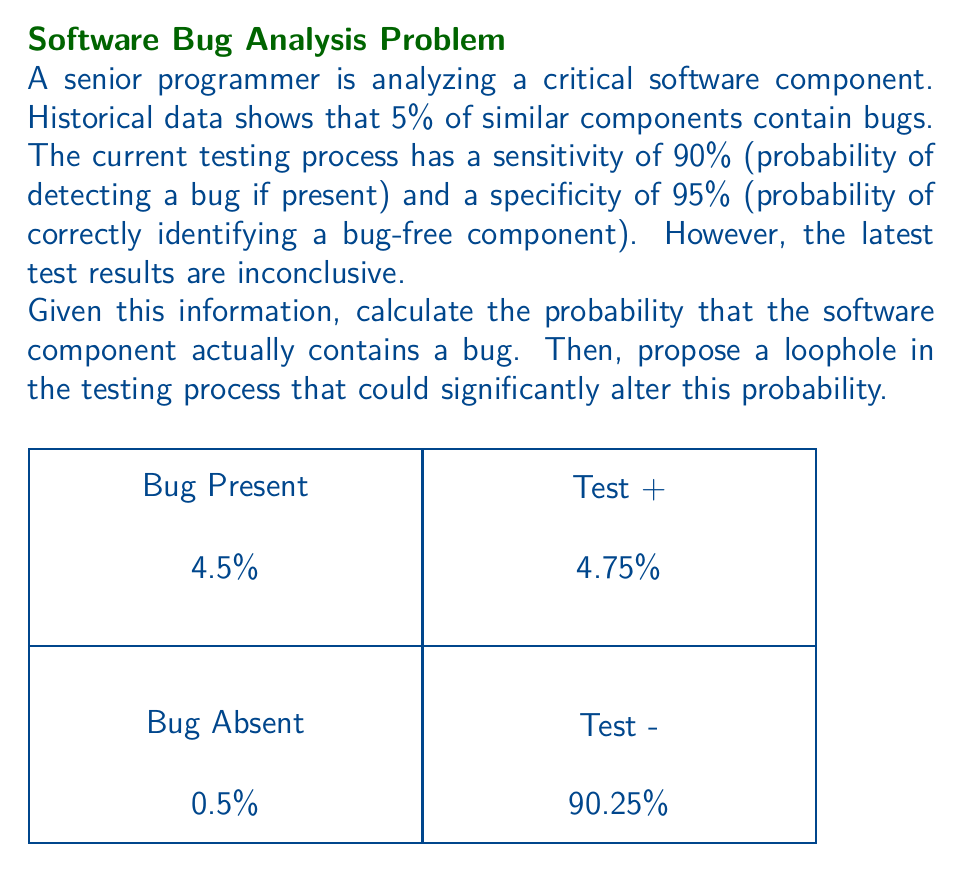Show me your answer to this math problem. Let's approach this step-by-step using Bayes' theorem:

1) Let B be the event that a bug is present, and T be the event of an inconclusive test.

2) We're given:
   P(B) = 0.05 (prior probability of a bug)
   P(T|B) = 1 - 0.90 = 0.10 (probability of inconclusive test given a bug)
   P(T|not B) = 1 - 0.95 = 0.05 (probability of inconclusive test given no bug)

3) Bayes' theorem states:

   $$P(B|T) = \frac{P(T|B) \cdot P(B)}{P(T)}$$

4) We need to calculate P(T):
   
   $$P(T) = P(T|B) \cdot P(B) + P(T|not B) \cdot P(not B)$$
   $$P(T) = 0.10 \cdot 0.05 + 0.05 \cdot 0.95 = 0.005 + 0.0475 = 0.0525$$

5) Now we can apply Bayes' theorem:

   $$P(B|T) = \frac{0.10 \cdot 0.05}{0.0525} = \frac{0.005}{0.0525} \approx 0.0952$$

6) Therefore, the probability of a bug being present given an inconclusive test is approximately 9.52%.

Loophole: A senior programmer might argue that the historical data of 5% bug rate is not applicable to this specific component due to its critical nature. They could propose that critical components undergo more rigorous development processes, potentially lowering the prior probability of a bug. If we assume a lower prior, say 1%, the calculation would yield a significantly lower posterior probability of a bug being present.
Answer: $P(B|T) \approx 0.0952$ or 9.52%. Loophole: Question the applicability of the 5% prior probability for critical components. 